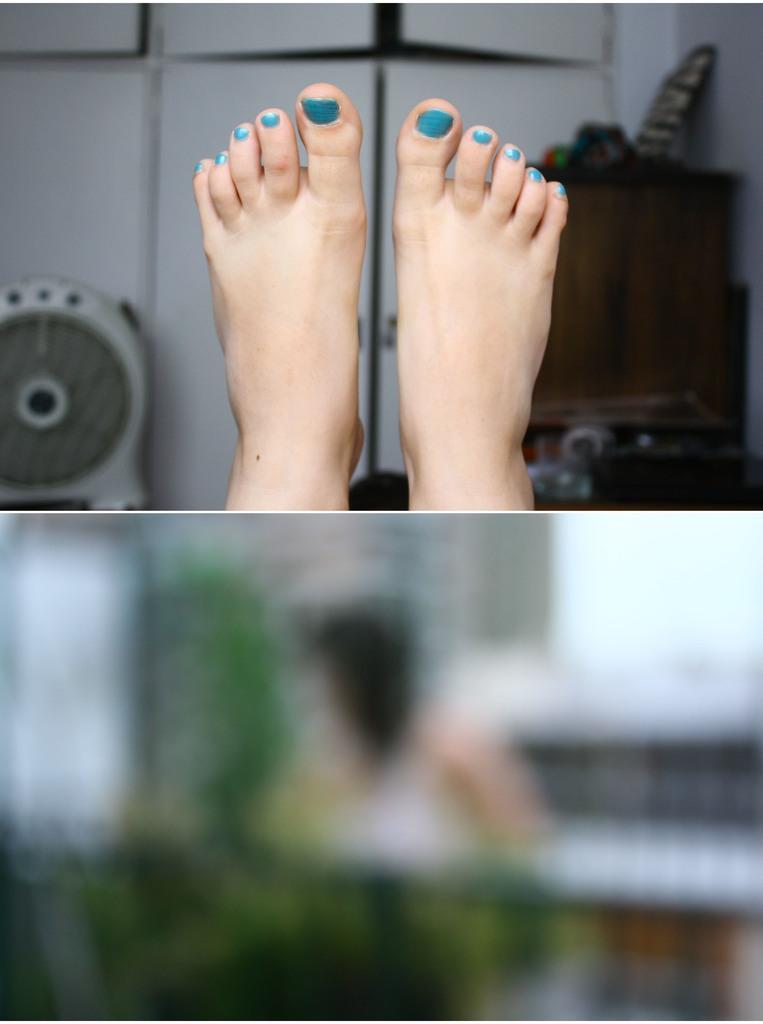In one or two sentences, can you explain what this image depicts? In this image I can see a person's legs and the wall and some other objects visible ,at the bottom I can see image is too blurry 